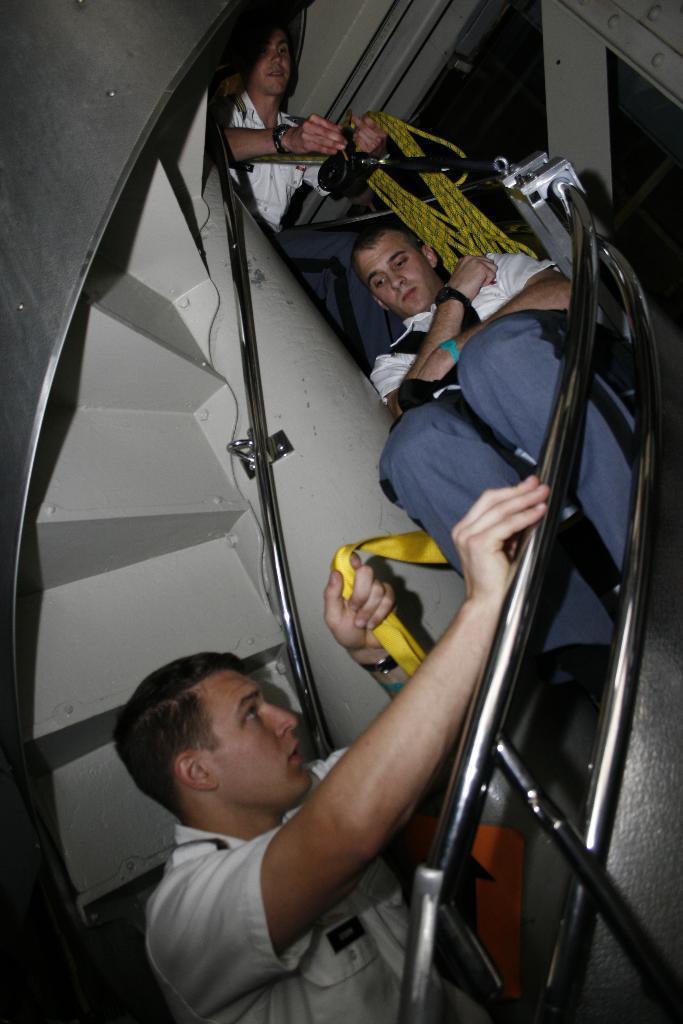Please provide a concise description of this image. In this image I can see three men where one man is holding a rope and another one is holding a yellow color of cloth. I can also see railing of stair. 